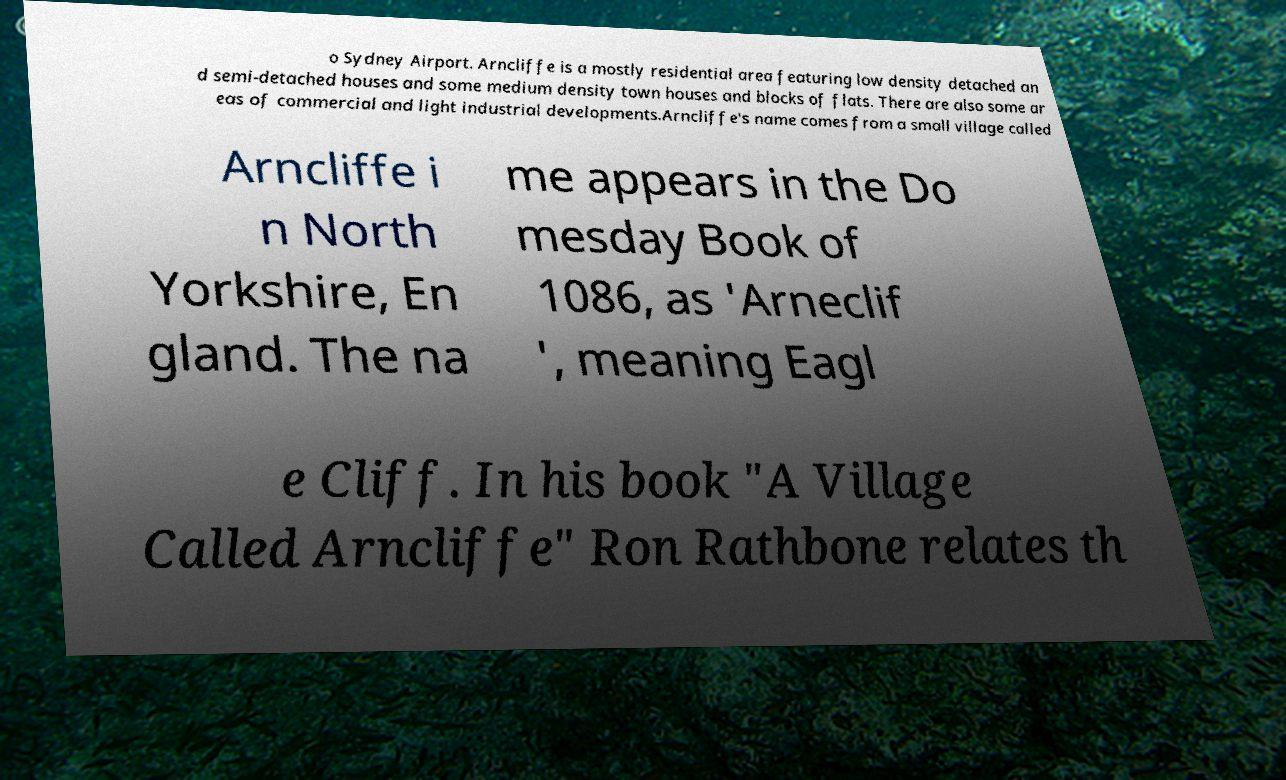What messages or text are displayed in this image? I need them in a readable, typed format. o Sydney Airport. Arncliffe is a mostly residential area featuring low density detached an d semi-detached houses and some medium density town houses and blocks of flats. There are also some ar eas of commercial and light industrial developments.Arncliffe's name comes from a small village called Arncliffe i n North Yorkshire, En gland. The na me appears in the Do mesday Book of 1086, as 'Arneclif ', meaning Eagl e Cliff. In his book "A Village Called Arncliffe" Ron Rathbone relates th 